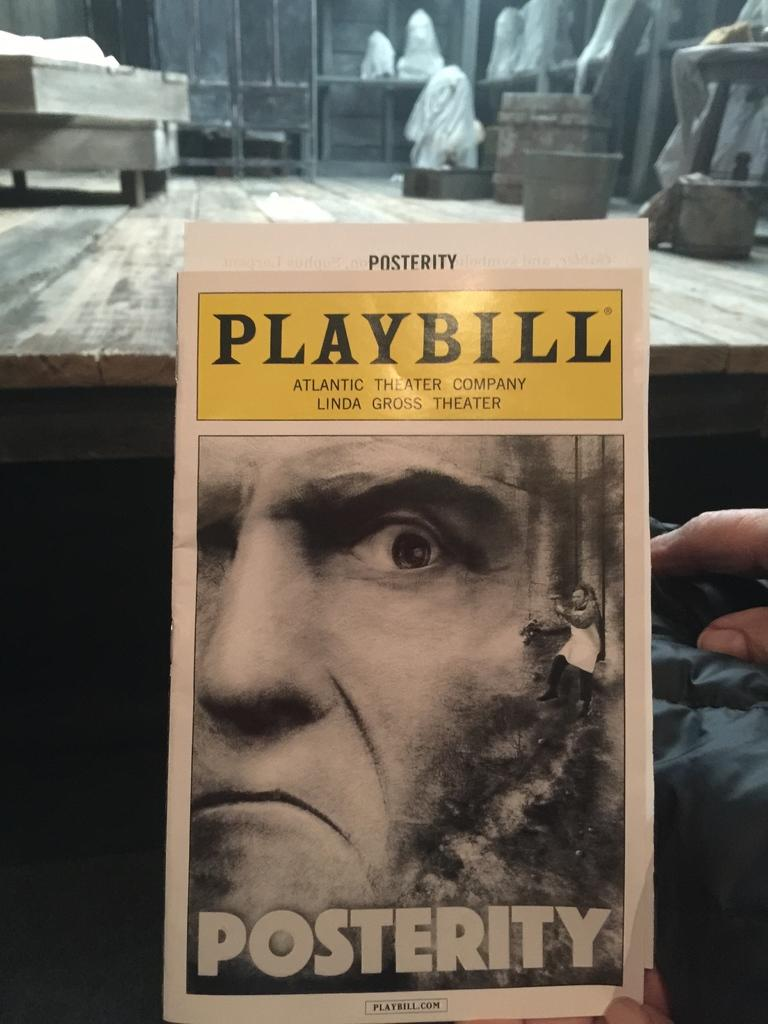<image>
Write a terse but informative summary of the picture. The playbill for posterity held on someones lap in front of a stage. 